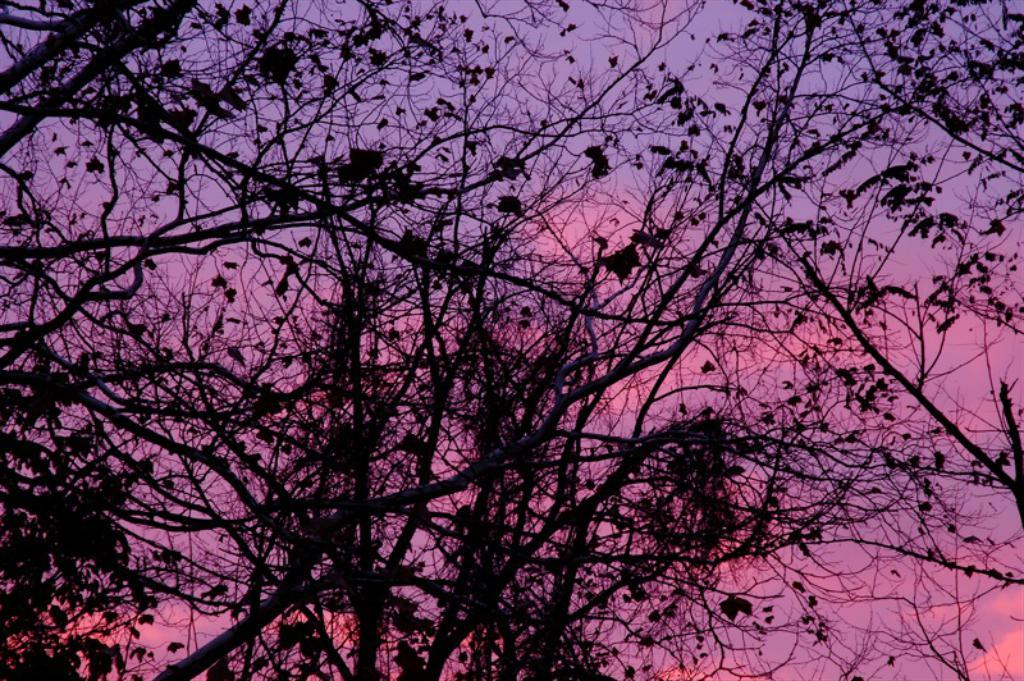Where was the picture taken? The picture was clicked outside. What can be seen in the foreground of the image? There are branches, leaves, and stems in the foreground of the image. What is visible in the background of the image? There is a sky visible in the background of the image. What type of plastic material can be seen in the image? There is no plastic material present in the image. Are there any shoes visible in the image? There are no shoes visible in the image. 